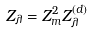Convert formula to latex. <formula><loc_0><loc_0><loc_500><loc_500>Z _ { \lambda } = Z _ { m } ^ { 2 } Z _ { \lambda } ^ { ( d ) }</formula> 